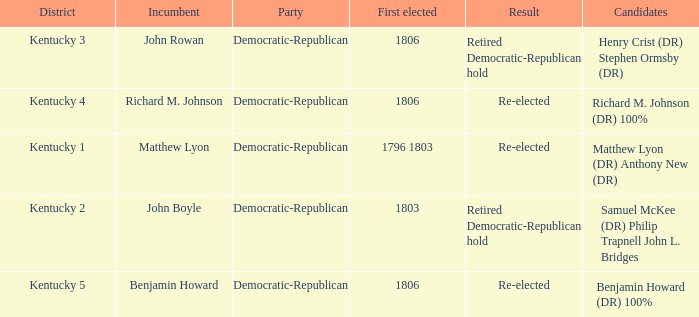Name the number of party for kentucky 1 1.0. 